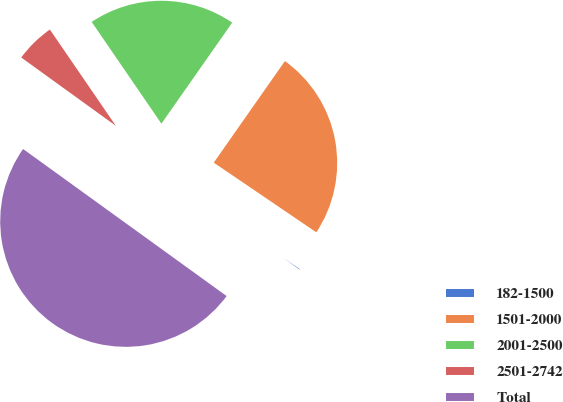<chart> <loc_0><loc_0><loc_500><loc_500><pie_chart><fcel>182-1500<fcel>1501-2000<fcel>2001-2500<fcel>2501-2742<fcel>Total<nl><fcel>0.46%<fcel>24.77%<fcel>19.29%<fcel>5.48%<fcel>50.0%<nl></chart> 